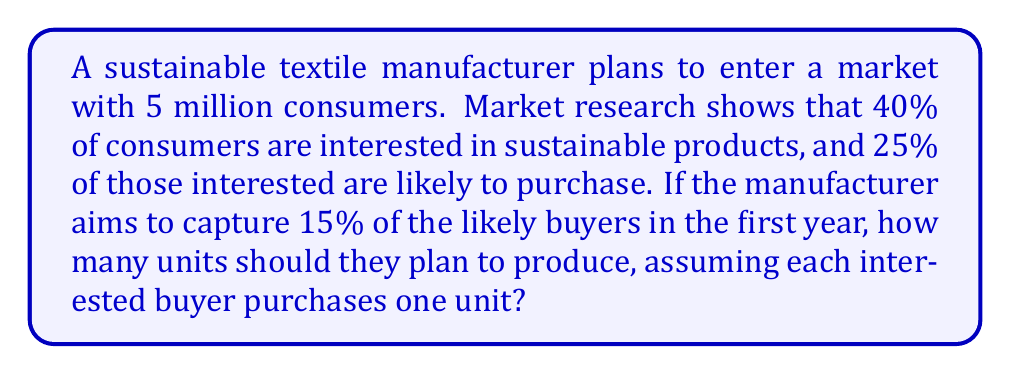Can you answer this question? Let's break this down step-by-step:

1. Calculate the number of consumers interested in sustainable products:
   $$ 5,000,000 \times 0.40 = 2,000,000 $$

2. Determine the number of likely buyers:
   $$ 2,000,000 \times 0.25 = 500,000 $$

3. Calculate the manufacturer's target market share:
   $$ 500,000 \times 0.15 = 75,000 $$

Therefore, the manufacturer should plan to produce 75,000 units to meet their target market share in the first year.
Answer: 75,000 units 